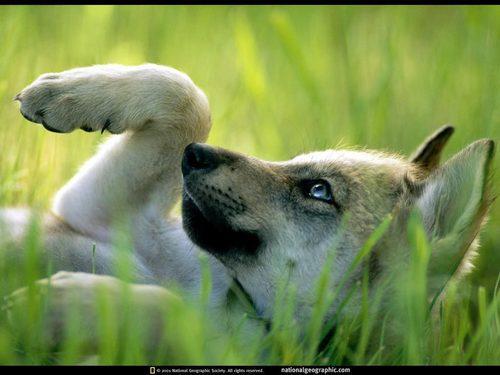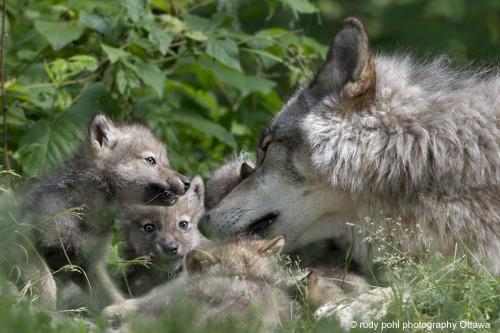The first image is the image on the left, the second image is the image on the right. For the images displayed, is the sentence "The right image features an adult wolf with left-turned face next to multiple pups." factually correct? Answer yes or no. Yes. The first image is the image on the left, the second image is the image on the right. Assess this claim about the two images: "There is a single wolf with its face partially covered by foliage in one of the images.". Correct or not? Answer yes or no. Yes. 